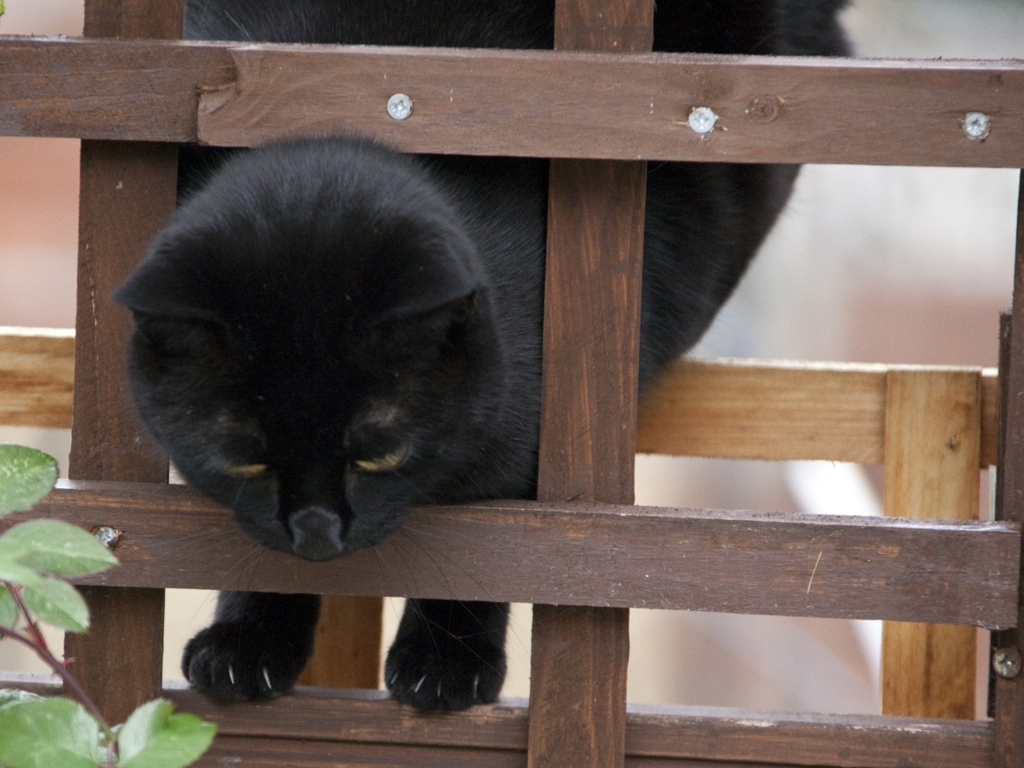Could you speculate what the cat might be looking at or thinking about? While we can never be certain of a cat's thoughts, one might speculate that it is closely observing something outside of the picture, such as a bird or a rustling leaf, indicated by its direct and focused gaze. Its body language suggests attentiveness and perhaps readiness to pounce, common behaviors when a cat is engaged by something intriguing. What elements of this image could indicate the time of day or season? The lighting in the image appears soft and diffuse, which could suggest it was taken in the early morning or late afternoon, times known for their gentle light. The presence of leaves on the plants implies it is not winter; possibly it's spring or summer when foliage is lush. 